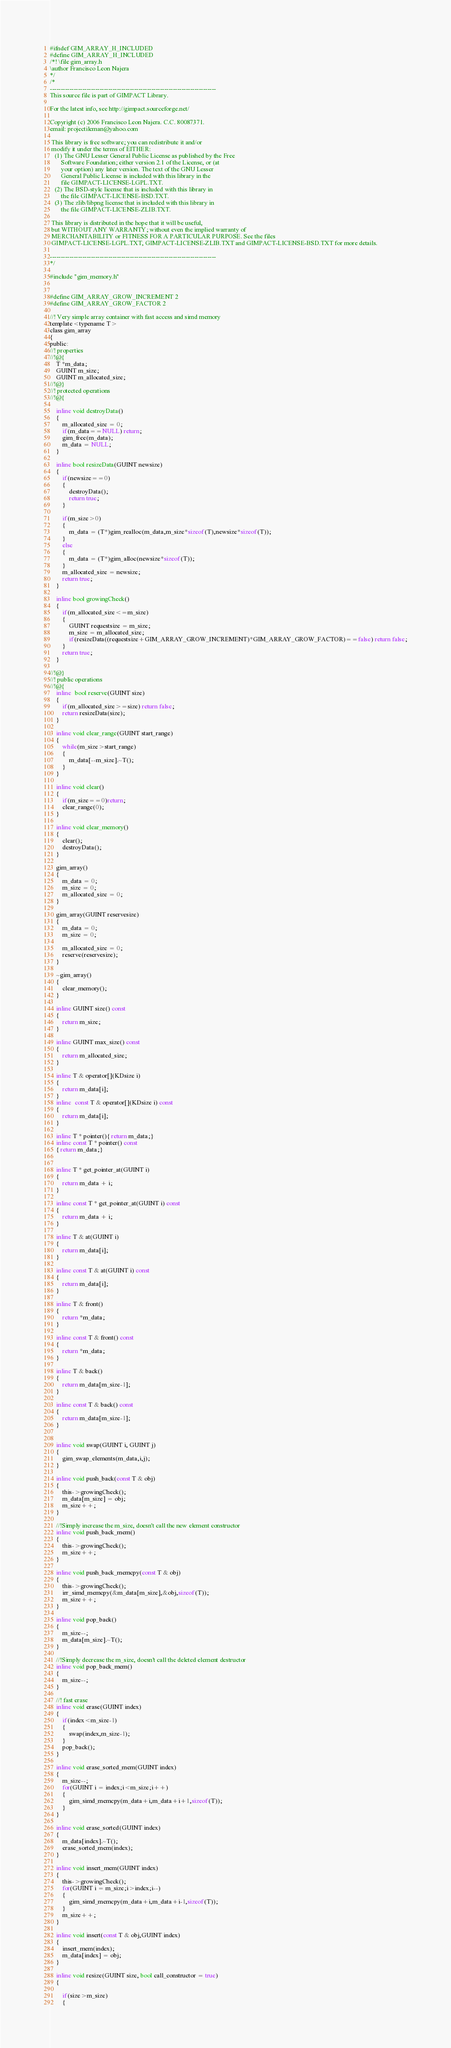Convert code to text. <code><loc_0><loc_0><loc_500><loc_500><_C_>#ifndef GIM_ARRAY_H_INCLUDED
#define GIM_ARRAY_H_INCLUDED
/*! \file gim_array.h
\author Francisco Leon Najera
*/
/*
-----------------------------------------------------------------------------
This source file is part of GIMPACT Library.

For the latest info, see http://gimpact.sourceforge.net/

Copyright (c) 2006 Francisco Leon Najera. C.C. 80087371.
email: projectileman@yahoo.com

 This library is free software; you can redistribute it and/or
 modify it under the terms of EITHER:
   (1) The GNU Lesser General Public License as published by the Free
       Software Foundation; either version 2.1 of the License, or (at
       your option) any later version. The text of the GNU Lesser
       General Public License is included with this library in the
       file GIMPACT-LICENSE-LGPL.TXT.
   (2) The BSD-style license that is included with this library in
       the file GIMPACT-LICENSE-BSD.TXT.
   (3) The zlib/libpng license that is included with this library in
       the file GIMPACT-LICENSE-ZLIB.TXT.

 This library is distributed in the hope that it will be useful,
 but WITHOUT ANY WARRANTY; without even the implied warranty of
 MERCHANTABILITY or FITNESS FOR A PARTICULAR PURPOSE. See the files
 GIMPACT-LICENSE-LGPL.TXT, GIMPACT-LICENSE-ZLIB.TXT and GIMPACT-LICENSE-BSD.TXT for more details.

-----------------------------------------------------------------------------
*/

#include "gim_memory.h"


#define GIM_ARRAY_GROW_INCREMENT 2
#define GIM_ARRAY_GROW_FACTOR 2

//!	Very simple array container with fast access and simd memory
template<typename T>
class gim_array
{
public:
//! properties
//!@{
    T *m_data;
    GUINT m_size;
    GUINT m_allocated_size;
//!@}
//! protected operations
//!@{

    inline void destroyData()
	{
	    m_allocated_size = 0;
		if(m_data==NULL) return;
		gim_free(m_data);
		m_data = NULL;
	}

	inline bool resizeData(GUINT newsize)
	{
		if(newsize==0)
		{
			destroyData();
			return true;
		}

		if(m_size>0)
		{
            m_data = (T*)gim_realloc(m_data,m_size*sizeof(T),newsize*sizeof(T));
		}
		else
		{
		    m_data = (T*)gim_alloc(newsize*sizeof(T));
		}
		m_allocated_size = newsize;
		return true;
	}

	inline bool growingCheck()
	{
		if(m_allocated_size<=m_size)
		{
		    GUINT requestsize = m_size;
		    m_size = m_allocated_size;
			if(resizeData((requestsize+GIM_ARRAY_GROW_INCREMENT)*GIM_ARRAY_GROW_FACTOR)==false) return false;
		}
		return true;
	}

//!@}
//! public operations
//!@{
    inline  bool reserve(GUINT size)
    {
        if(m_allocated_size>=size) return false;
        return resizeData(size);
    }

    inline void clear_range(GUINT start_range)
    {
        while(m_size>start_range)
        {
            m_data[--m_size].~T();
        }
    }

    inline void clear()
    {
        if(m_size==0)return;
        clear_range(0);
    }

    inline void clear_memory()
    {
        clear();
        destroyData();
    }

    gim_array()
    {
        m_data = 0;
        m_size = 0;
        m_allocated_size = 0;
    }

    gim_array(GUINT reservesize)
    {
        m_data = 0;
        m_size = 0;

        m_allocated_size = 0;
        reserve(reservesize);
    }

    ~gim_array()
    {
        clear_memory();
    }

    inline GUINT size() const
    {
        return m_size;
    }

    inline GUINT max_size() const
    {
        return m_allocated_size;
    }

    inline T & operator[](KDsize i)
	{
		return m_data[i];
	}
	inline  const T & operator[](KDsize i) const
	{
		return m_data[i];
	}

    inline T * pointer(){ return m_data;}
    inline const T * pointer() const
    { return m_data;}


    inline T * get_pointer_at(GUINT i)
	{
		return m_data + i;
	}

	inline const T * get_pointer_at(GUINT i) const
	{
		return m_data + i;
	}

	inline T & at(GUINT i)
	{
		return m_data[i];
	}

	inline const T & at(GUINT i) const
	{
		return m_data[i];
	}

	inline T & front()
	{
		return *m_data;
	}

	inline const T & front() const
	{
		return *m_data;
	}

	inline T & back()
	{
		return m_data[m_size-1];
	}

	inline const T & back() const
	{
		return m_data[m_size-1];
	}


	inline void swap(GUINT i, GUINT j)
	{
	    gim_swap_elements(m_data,i,j);
	}

	inline void push_back(const T & obj)
	{
	    this->growingCheck();
	    m_data[m_size] = obj;
	    m_size++;
	}

	//!Simply increase the m_size, doesn't call the new element constructor
	inline void push_back_mem()
	{
	    this->growingCheck();
	    m_size++;
	}

	inline void push_back_memcpy(const T & obj)
	{
	    this->growingCheck();
	    irr_simd_memcpy(&m_data[m_size],&obj,sizeof(T));
	    m_size++;
	}

	inline void pop_back()
	{
	    m_size--;
        m_data[m_size].~T();
	}

	//!Simply decrease the m_size, doesn't call the deleted element destructor
	inline void pop_back_mem()
	{
	    m_size--;
	}

    //! fast erase
	inline void erase(GUINT index)
	{
	    if(index<m_size-1)
	    {
	        swap(index,m_size-1);
	    }
	    pop_back();
	}

	inline void erase_sorted_mem(GUINT index)
	{
	    m_size--;
	    for(GUINT i = index;i<m_size;i++)
	    {
	        gim_simd_memcpy(m_data+i,m_data+i+1,sizeof(T));
	    }
	}

	inline void erase_sorted(GUINT index)
	{
	    m_data[index].~T();
	    erase_sorted_mem(index);
	}

	inline void insert_mem(GUINT index)
	{
	    this->growingCheck();
	    for(GUINT i = m_size;i>index;i--)
	    {
	        gim_simd_memcpy(m_data+i,m_data+i-1,sizeof(T));
	    }
	    m_size++;
	}

	inline void insert(const T & obj,GUINT index)
	{
	    insert_mem(index);
	    m_data[index] = obj;
	}

	inline void resize(GUINT size, bool call_constructor = true)
	{

	    if(size>m_size)
	    {</code> 